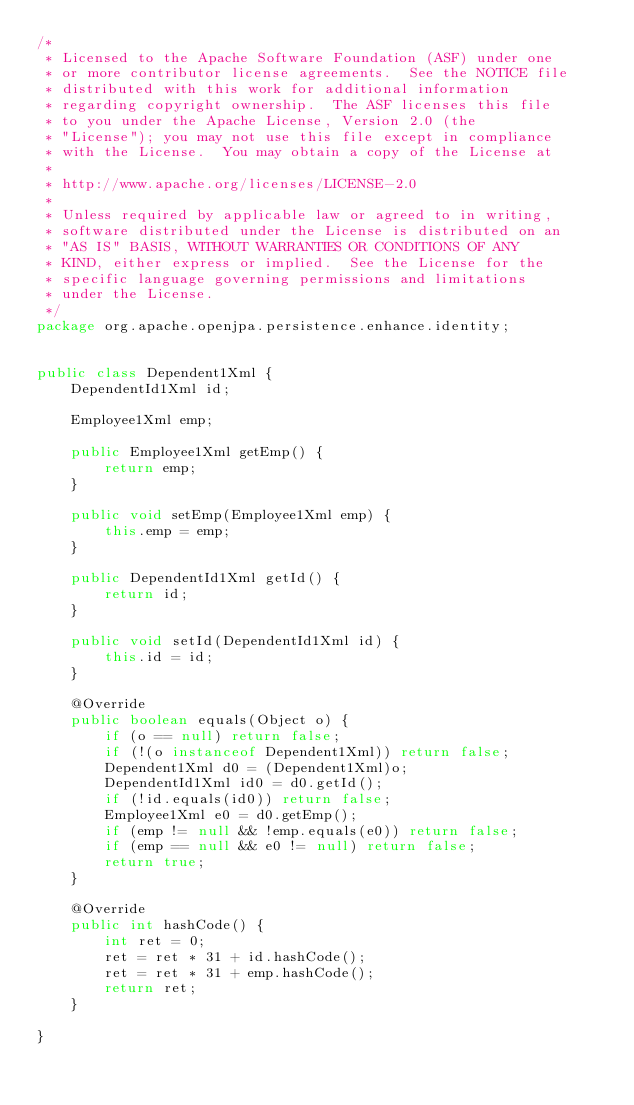<code> <loc_0><loc_0><loc_500><loc_500><_Java_>/*
 * Licensed to the Apache Software Foundation (ASF) under one
 * or more contributor license agreements.  See the NOTICE file
 * distributed with this work for additional information
 * regarding copyright ownership.  The ASF licenses this file
 * to you under the Apache License, Version 2.0 (the
 * "License"); you may not use this file except in compliance
 * with the License.  You may obtain a copy of the License at
 *
 * http://www.apache.org/licenses/LICENSE-2.0
 *
 * Unless required by applicable law or agreed to in writing,
 * software distributed under the License is distributed on an
 * "AS IS" BASIS, WITHOUT WARRANTIES OR CONDITIONS OF ANY
 * KIND, either express or implied.  See the License for the
 * specific language governing permissions and limitations
 * under the License.
 */
package org.apache.openjpa.persistence.enhance.identity;


public class Dependent1Xml {
    DependentId1Xml id;

    Employee1Xml emp;

    public Employee1Xml getEmp() {
        return emp;
    }

    public void setEmp(Employee1Xml emp) {
        this.emp = emp;
    }

    public DependentId1Xml getId() {
        return id;
    }

    public void setId(DependentId1Xml id) {
        this.id = id;
    }

    @Override
    public boolean equals(Object o) {
        if (o == null) return false;
        if (!(o instanceof Dependent1Xml)) return false;
        Dependent1Xml d0 = (Dependent1Xml)o;
        DependentId1Xml id0 = d0.getId();
        if (!id.equals(id0)) return false;
        Employee1Xml e0 = d0.getEmp();
        if (emp != null && !emp.equals(e0)) return false;
        if (emp == null && e0 != null) return false;
        return true;
    }

    @Override
    public int hashCode() {
        int ret = 0;
        ret = ret * 31 + id.hashCode();
        ret = ret * 31 + emp.hashCode();
        return ret;
    }

}
</code> 